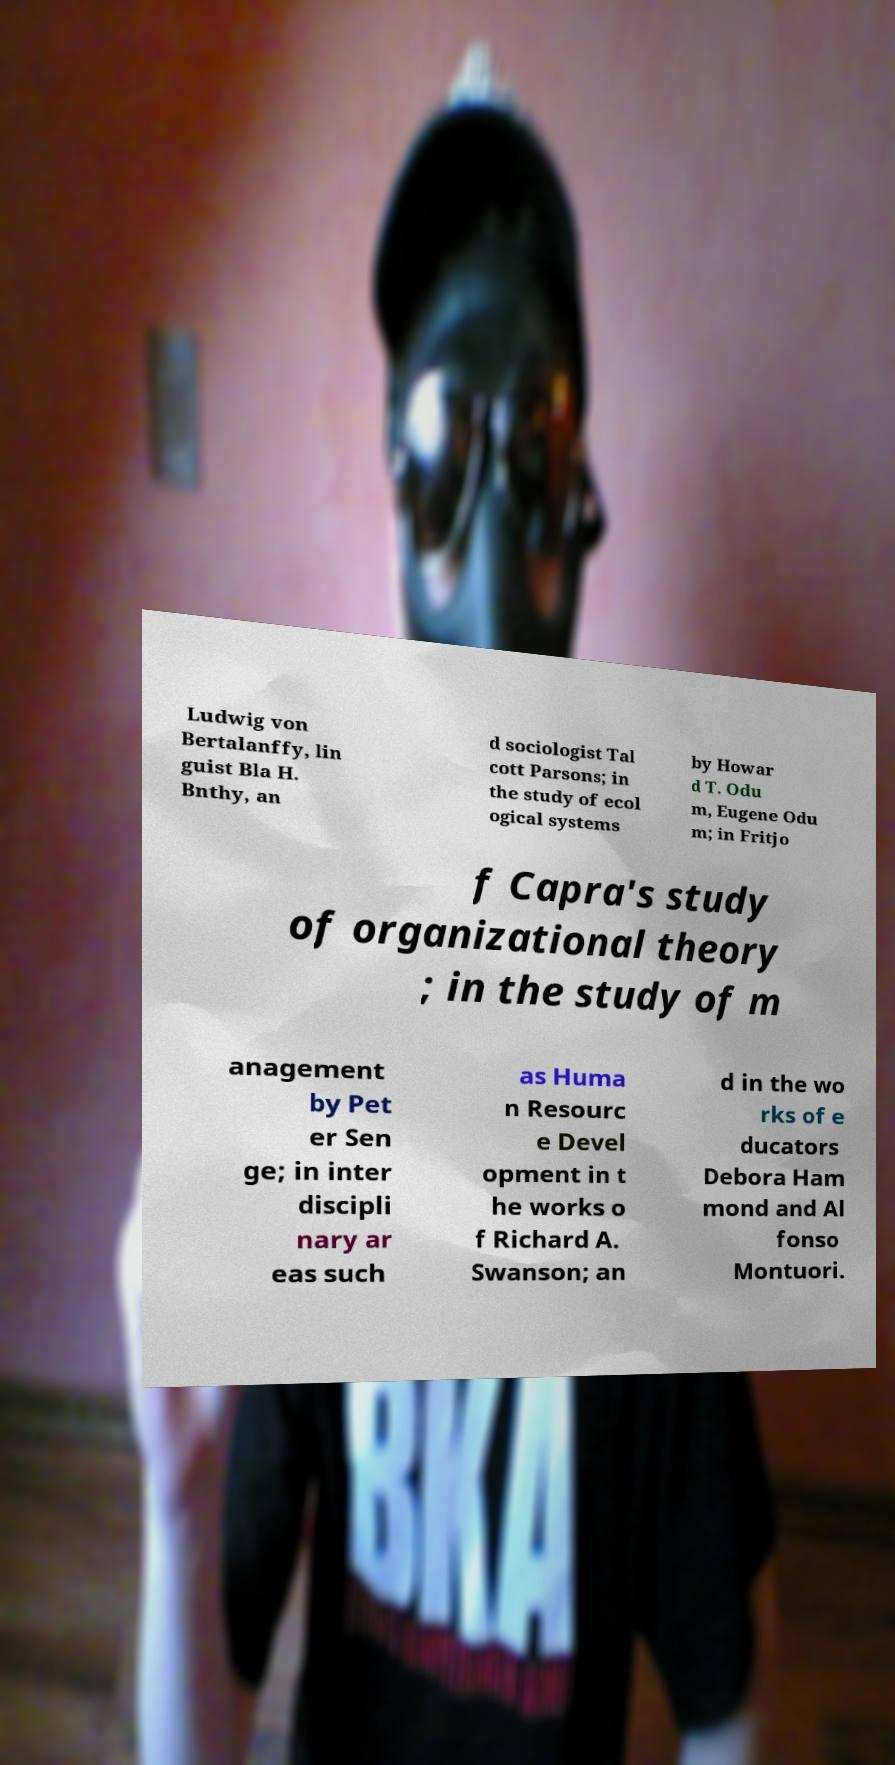Could you assist in decoding the text presented in this image and type it out clearly? Ludwig von Bertalanffy, lin guist Bla H. Bnthy, an d sociologist Tal cott Parsons; in the study of ecol ogical systems by Howar d T. Odu m, Eugene Odu m; in Fritjo f Capra's study of organizational theory ; in the study of m anagement by Pet er Sen ge; in inter discipli nary ar eas such as Huma n Resourc e Devel opment in t he works o f Richard A. Swanson; an d in the wo rks of e ducators Debora Ham mond and Al fonso Montuori. 